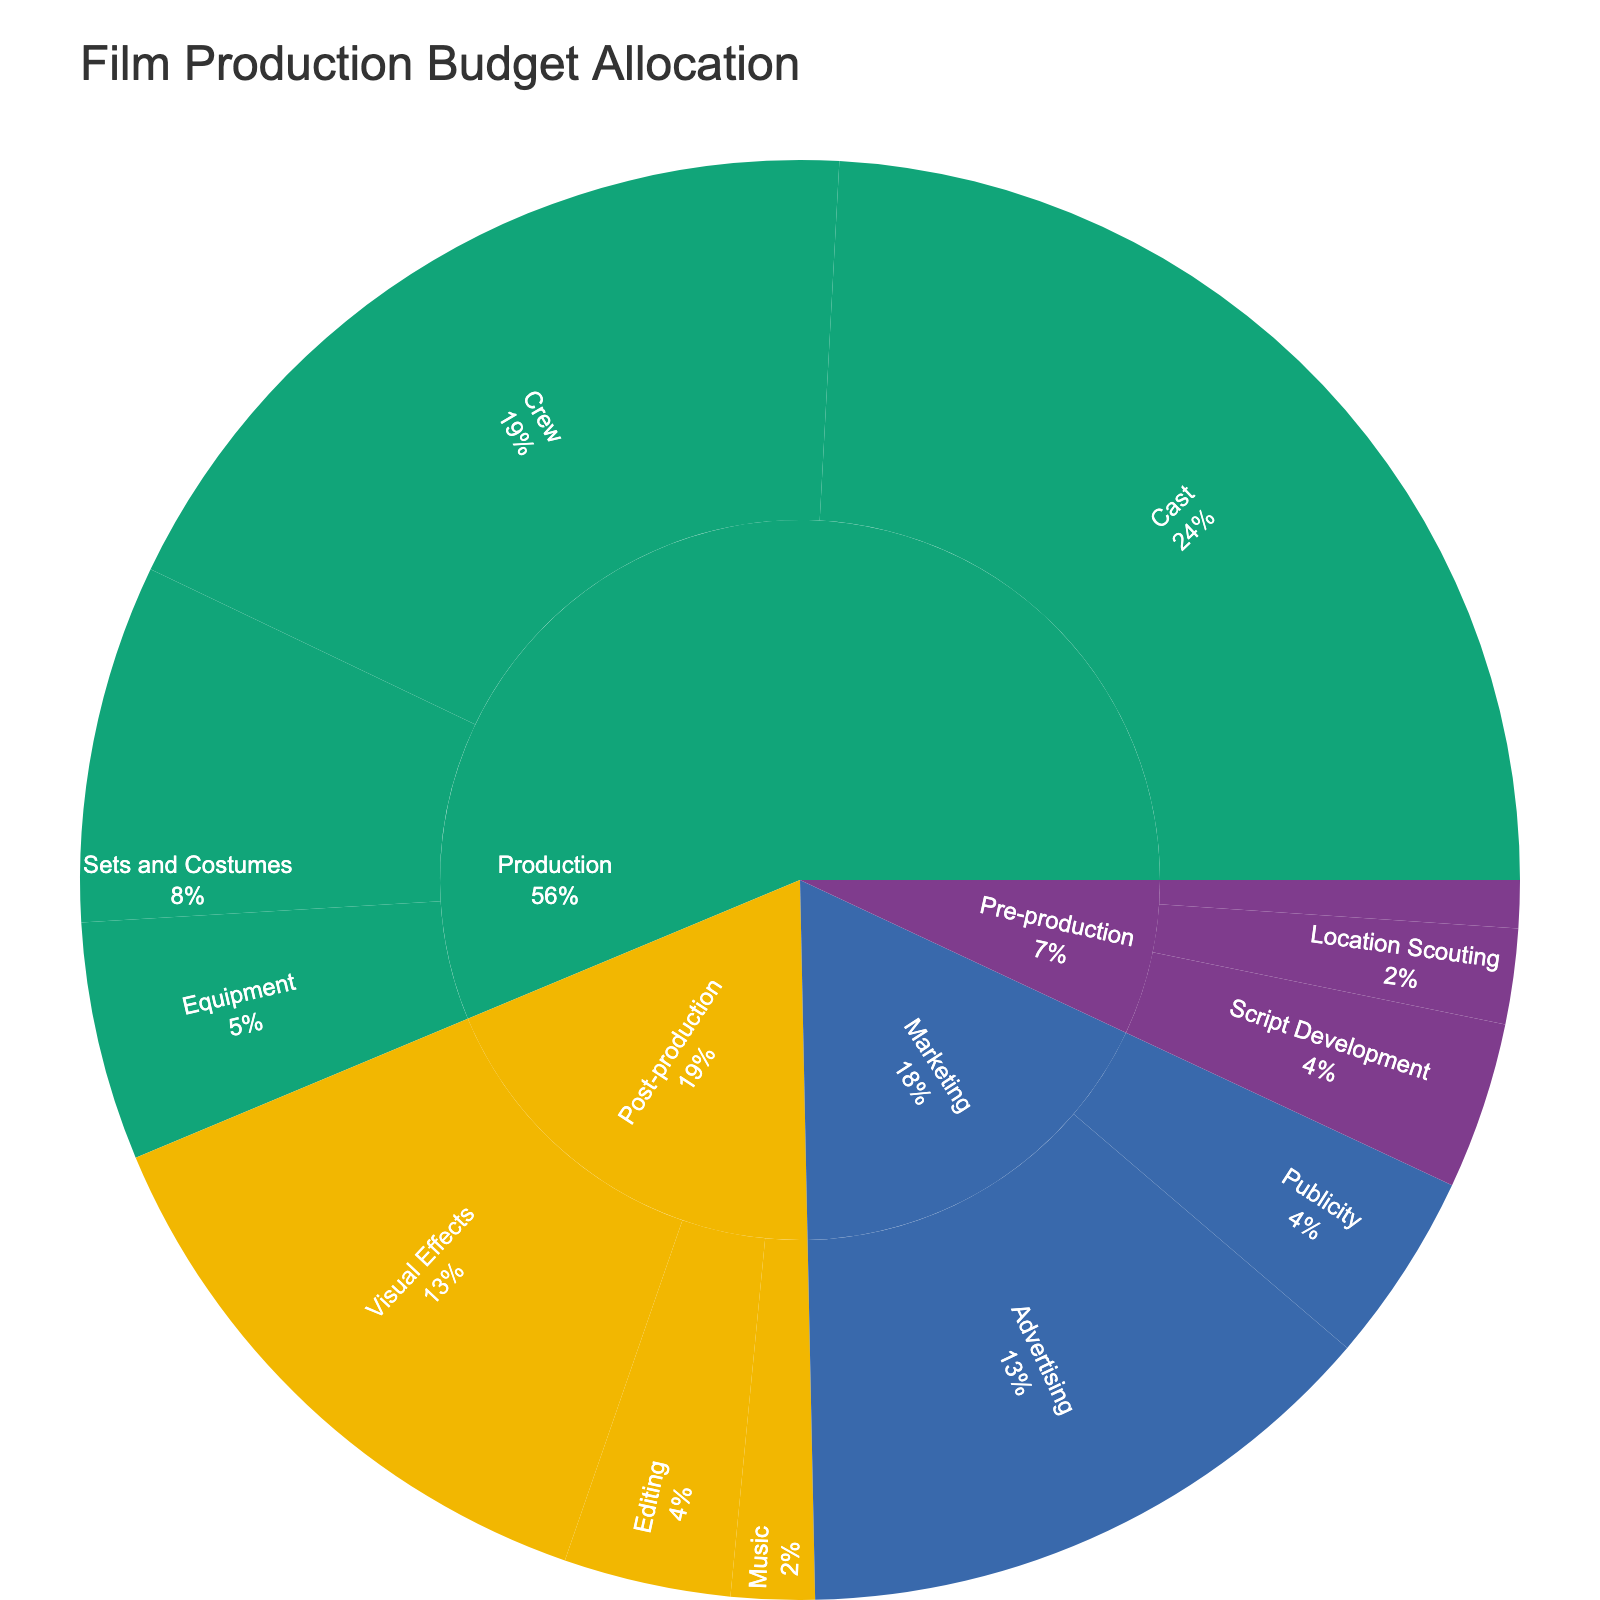What's the title of the figure? The title of the figure is located at the top. It reads "Film Production Budget Allocation."
Answer: Film Production Budget Allocation Which category has the highest budget allocation? By looking at the largest section in the plot, we can see that the "Production" category has the highest budget allocation, indicated by its larger area compared to other categories.
Answer: Production What is the total budget for the "Editing" subcategory? The "Editing" subcategory under "Post-production" includes "Picture Editing" ($4,000,000) and "Sound Editing" ($3,000,000). Summing these values gives $4,000,000 + $3,000,000 = $7,000,000.
Answer: $7,000,000 Which subcategory under "Production" has the smallest budget? Under "Production," the subcategories are "Cast," "Crew," "Equipment," and "Sets and Costumes." We compare the areas and see that "Equipment" ($10,000,000) is the smallest.
Answer: Equipment How does the budget for "Location Scouting" compare to "Casting" in "Pre-production"? The "Location Scouting" subcategory has a budget of $1,000,000 (Travel Expenses) + $3,000,000 (Location Fees) = $4,000,000. The "Casting" subcategory has a budget of $1,500,000 (Casting Director Fees) + $500,000 (Actor Auditions) = $2,000,000. Therefore, "Location Scouting" has twice the budget of "Casting."
Answer: Location Scouting has twice the budget of Casting What percentage of the "Marketing" category budget is allocated to "TV Commercials"? "Marketing" includes "TV Commercials" ($15,000,000), "Online Ads" ($10,000,000), "Press Junkets" ($3,000,000), and "Premiere Events" ($5,000,000). The total marketing budget is $33,000,000. The percentage for "TV Commercials" is ($15,000,000 / $33,000,000) * 100 ≈ 45.45%.
Answer: Approximately 45.45% Between "Composer" and "Orchestra Recording" in "Post-production", which has a higher budget and by how much? "Composer" has a budget of $2,000,000, and "Orchestra Recording" has a budget of $1,500,000. The difference is $2,000,000 - $1,500,000 = $500,000.
Answer: Composer has a higher budget by $500,000 What is the combined budget for the "Equipment" subcategory in "Production"? The "Equipment" subcategory includes "Camera Equipment" ($5,000,000), "Lighting Equipment" ($3,000,000), and "Sound Equipment" ($2,000,000). The combined budget is $5,000,000 + $3,000,000 + $2,000,000 = $10,000,000.
Answer: $10,000,000 Which item in the "Post-production" category has the highest budget? In the "Post-production" category, the largest budget item is "CGI" within the "Visual Effects" subcategory, with a budget of $20,000,000.
Answer: CGI How does the budget for "Lead Actors" compare to the entire "Post-production" budget? The budget for "Lead Actors" is $30,000,000. The entire "Post-production" budget is $4,000,000 (Picture Editing) + $3,000,000 (Sound Editing) + $20,000,000 (CGI) + $5,000,000 (Compositing) + $2,000,000 (Composer) + $1,500,000 (Orchestra Recording) = $35,500,000. "Lead Actors" budget is slightly less than the entire "Post-production" budget.
Answer: Slightly less 